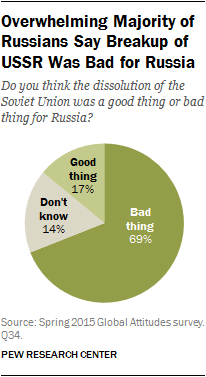Outline some significant characteristics in this image. There is a chart with a percentage of Don't know, and the percentage is 14%. The difference between the percentage of a bad thing and a good thing is 52... 